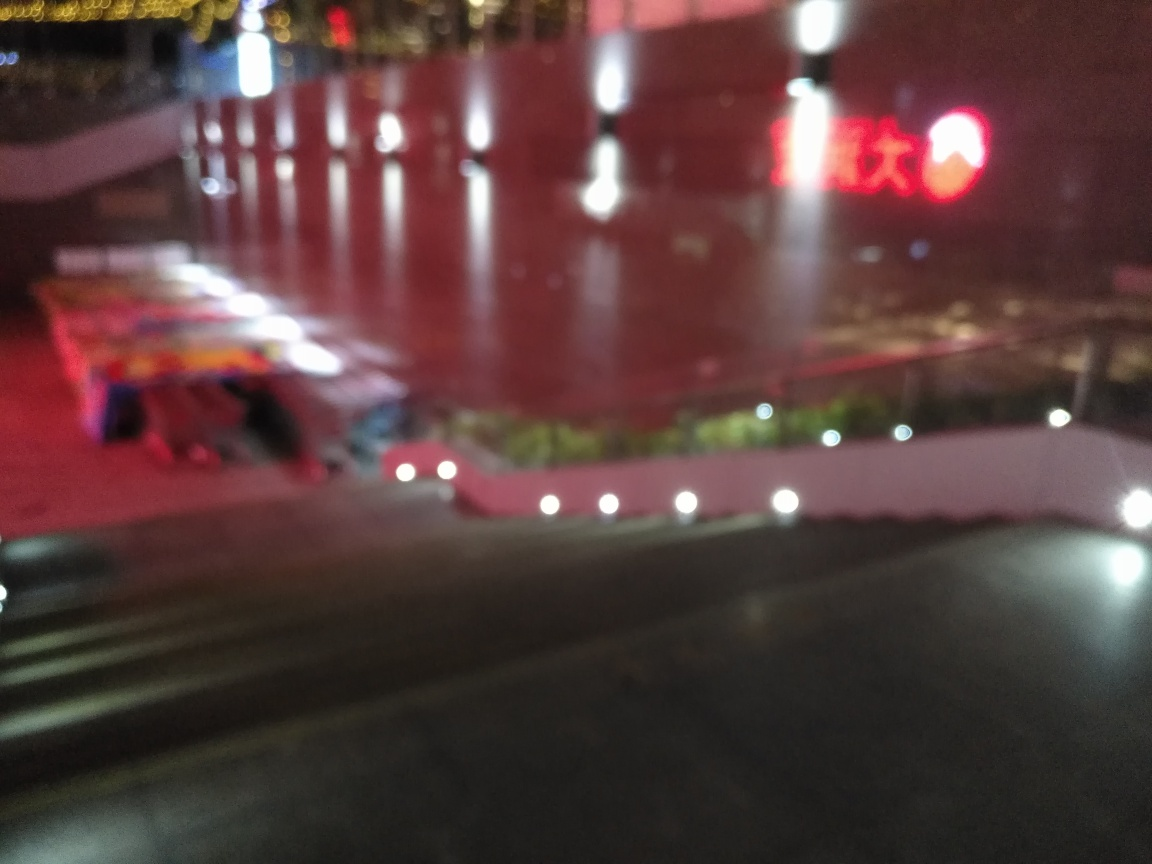What mood or atmosphere is conveyed by this image? The image evokes a sense of stillness and solitude, accentuated by the blurring effects that soften the urban environment. The warm glows and reflections suggest a tranquil, perhaps introspective moment experienced in the city at night. What are the possible reasons for the blurriness in this image? The blurriness could be due to several factors: a camera's shallow depth of field, a focus malfunction, or motion blur from a long exposure without a steady hand or tripod. It may also be a stylistic choice by the photographer to convey a particular artistic vision or emotion. 